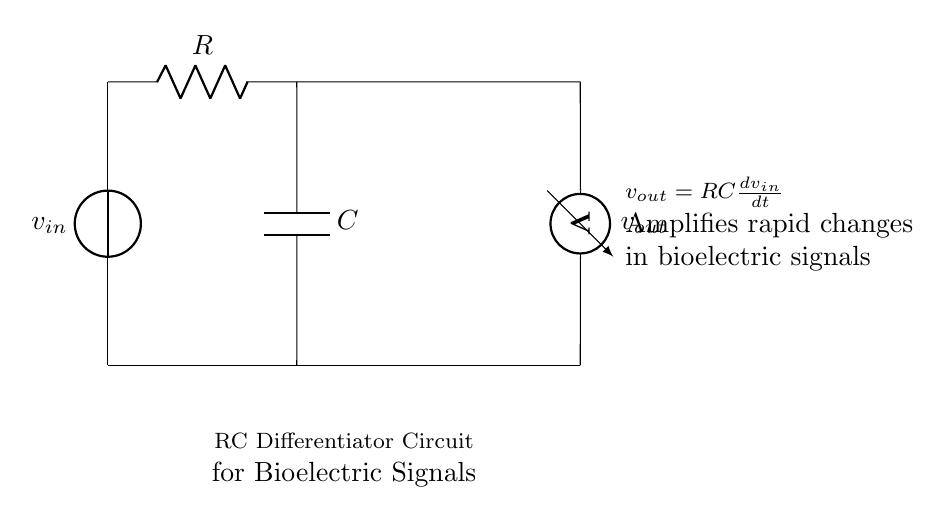What are the main components in this circuit? The main components are a resistor, a capacitor, and a voltage source. The resistor is labeled "R" and the capacitor is labeled "C." The voltage source provides the input signal denoted as "v_in."
Answer: resistor, capacitor, voltage source What does the output voltage represent? The output voltage "v_out" represents the amplified response of the circuit to rapid changes in the input bioelectric signals. This amplification is due to the derivative action of the differentiator circuit.
Answer: amplified bioelectric signal What is the function of the resistor in this circuit? The resistor limits the current flow and defines the time constant of the circuit along with the capacitor. It helps shape the output voltage when the input voltage changes.
Answer: current limiting and time constant What is the relationship between input voltage and output voltage in this circuit? The relationship is expressed by the equation "v_out = RC * (dv_in/dt)," indicating that the output voltage is proportional to the rate of change of the input voltage. The constant "RC" represents the time constant of the circuit.
Answer: v_out = RC * (dv_in/dt) How does this circuit respond to a rapid increase in the bioelectric signal? A rapid increase in the bioelectric signal results in a quick change in the input voltage (dv_in/dt), which leads to a significant increase in the output voltage due to the amplification aspect of the differentiator.
Answer: significant increase in v_out What type of circuit is this specifically classified as? This circuit is classified as an RC differentiator circuit. It is designed specifically to analyze rapid changes in input signals such as bioelectric signals.
Answer: RC differentiator circuit 